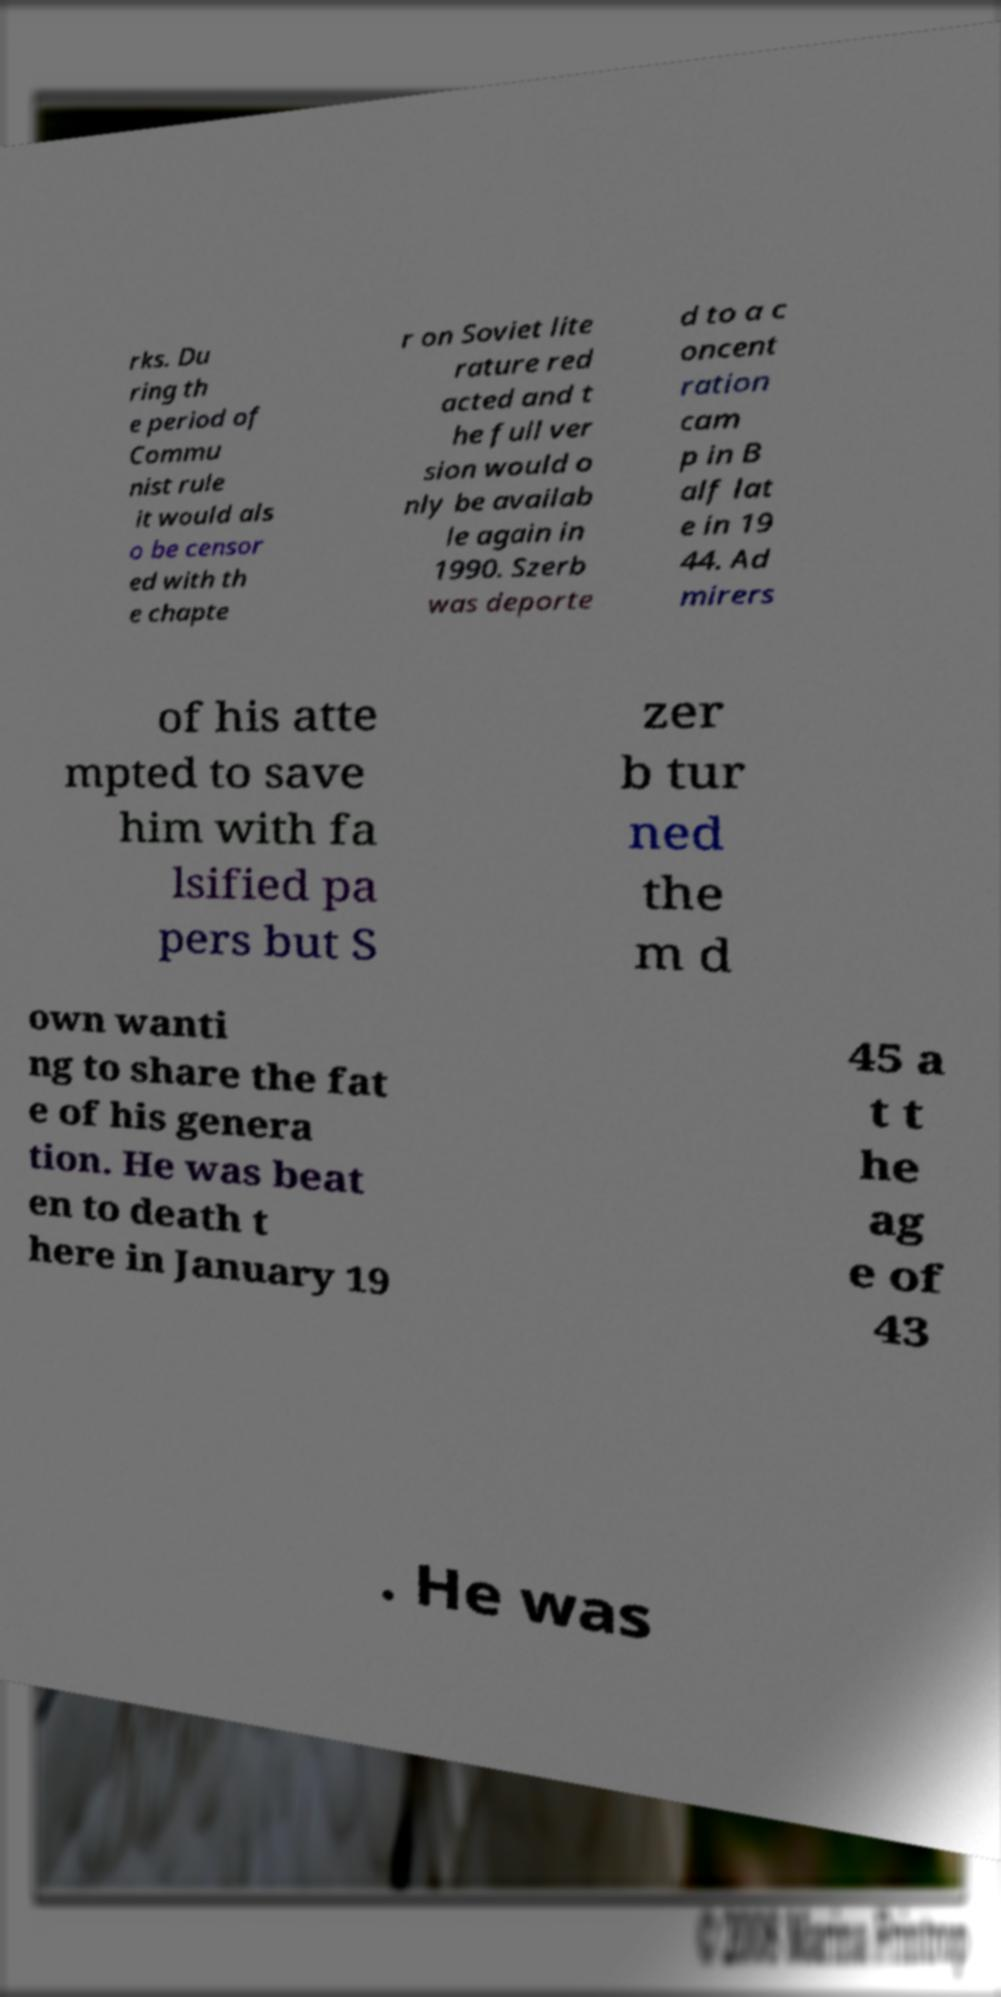For documentation purposes, I need the text within this image transcribed. Could you provide that? rks. Du ring th e period of Commu nist rule it would als o be censor ed with th e chapte r on Soviet lite rature red acted and t he full ver sion would o nly be availab le again in 1990. Szerb was deporte d to a c oncent ration cam p in B alf lat e in 19 44. Ad mirers of his atte mpted to save him with fa lsified pa pers but S zer b tur ned the m d own wanti ng to share the fat e of his genera tion. He was beat en to death t here in January 19 45 a t t he ag e of 43 . He was 